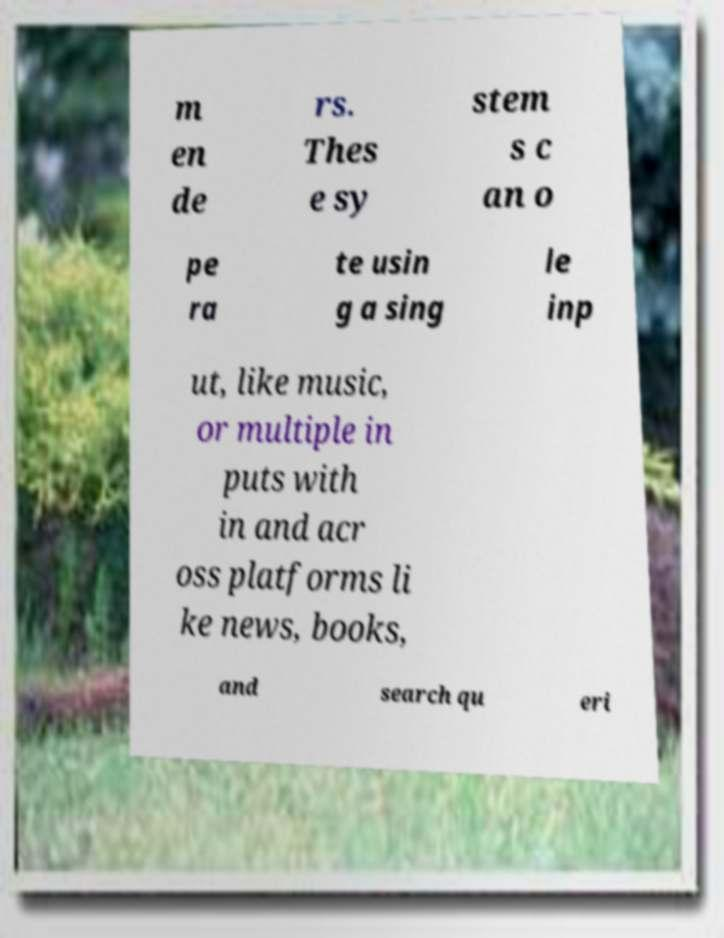Could you assist in decoding the text presented in this image and type it out clearly? m en de rs. Thes e sy stem s c an o pe ra te usin g a sing le inp ut, like music, or multiple in puts with in and acr oss platforms li ke news, books, and search qu eri 